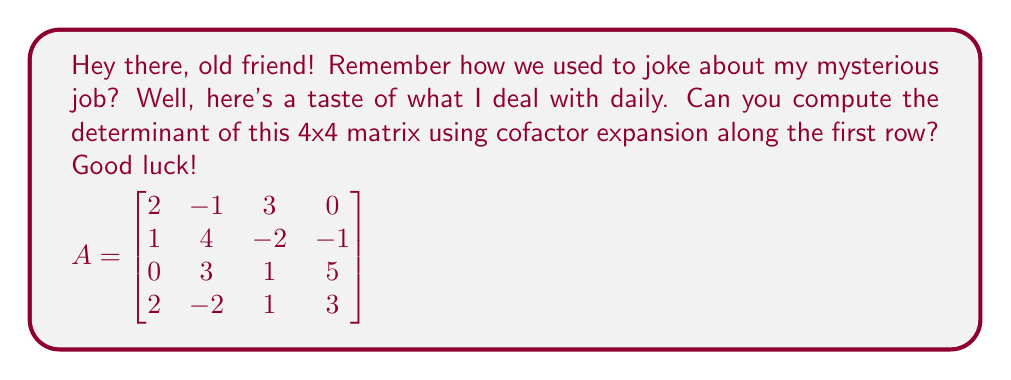Can you answer this question? To compute the determinant of a 4x4 matrix using cofactor expansion along the first row, we use the formula:

$$\det(A) = \sum_{j=1}^n a_{1j} \cdot (-1)^{1+j} \cdot M_{1j}$$

where $a_{1j}$ is the element in the first row and $j$-th column, and $M_{1j}$ is the minor of $a_{1j}$ (the determinant of the 3x3 matrix formed by deleting the first row and $j$-th column).

Let's expand along the first row:

1) For $a_{11} = 2$:
   $$M_{11} = \det\begin{bmatrix}
   4 & -2 & -1 \\
   3 & 1 & 5 \\
   -2 & 1 & 3
   \end{bmatrix} = 4(3) - (-2)(15) - (-1)(-7) = 12 + 30 - 7 = 35$$

2) For $a_{12} = -1$:
   $$M_{12} = \det\begin{bmatrix}
   1 & -2 & -1 \\
   0 & 1 & 5 \\
   2 & 1 & 3
   \end{bmatrix} = 1(3) - (-2)(10) - (-1)(2) = 3 + 20 + 2 = 25$$

3) For $a_{13} = 3$:
   $$M_{13} = \det\begin{bmatrix}
   1 & 4 & -1 \\
   0 & 3 & 5 \\
   2 & -2 & 3
   \end{bmatrix} = 1(9+10) - 4(0+10) - (-1)(6-0) = 19 - 40 + 6 = -15$$

4) For $a_{14} = 0$:
   $$M_{14} = \det\begin{bmatrix}
   1 & 4 & -2 \\
   0 & 3 & 1 \\
   2 & -2 & 1
   \end{bmatrix} = 1(3+4) - 4(0+2) - (-2)(3-0) = 7 - 8 + 6 = 5$$

Now, we can calculate the determinant:

$$\begin{align*}
\det(A) &= 2 \cdot (-1)^{1+1} \cdot 35 + (-1) \cdot (-1)^{1+2} \cdot 25 + 3 \cdot (-1)^{1+3} \cdot (-15) + 0 \cdot (-1)^{1+4} \cdot 5 \\
&= 2 \cdot 35 - 25 - 3 \cdot 15 + 0 \\
&= 70 - 25 - 45 \\
&= 0
\end{align*}$$
Answer: $\det(A) = 0$ 